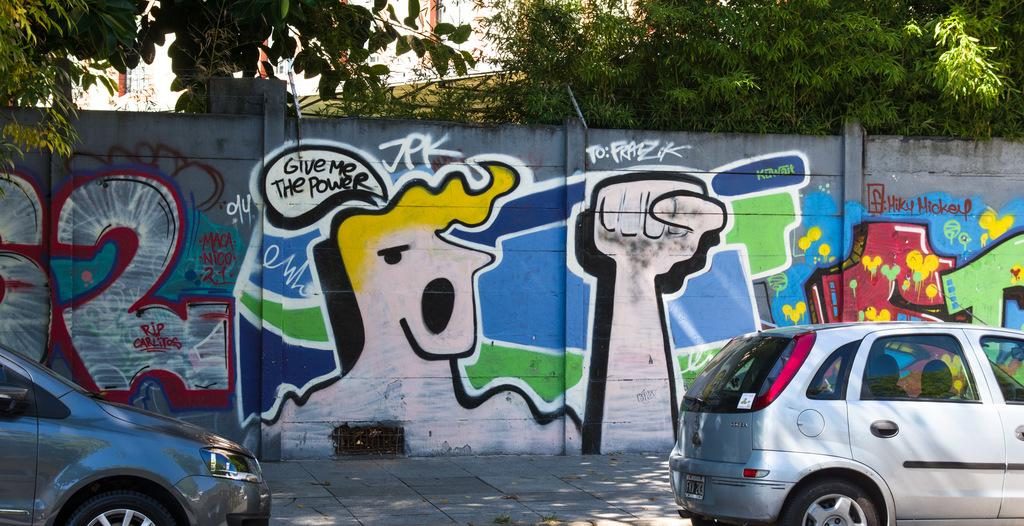What type of vehicles can be seen in the image? There are cars in the image. What is on the wall in the background of the image? There is a painting on the wall in the background of the image. What type of natural elements are visible in the background of the image? There are trees in the background of the image. What type of man-made structures can be seen in the background of the image? There are buildings in the background of the image. How many eggs are visible on the cars in the image? There are no eggs visible on the cars in the image. What type of pencil is being used to draw the painting on the wall in the image? There is no pencil visible in the image, and the painting on the wall is not being created in the image. 